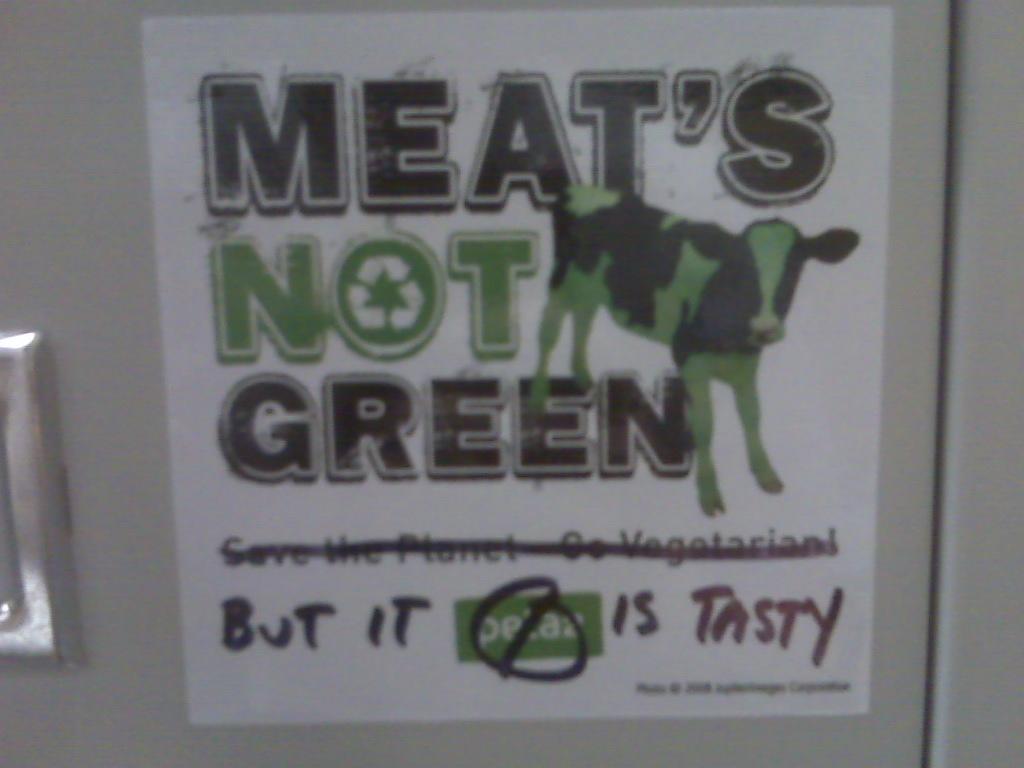What is featured in the image? There is a poster in the image. What can be found on the poster? The poster contains text and a picture of a cow. What type of trail can be seen behind the cow in the image? There is no trail visible in the image; the poster only contains text and a picture of a cow. What instrument is the cow playing in the image? There is no instrument or cow playing an instrument in the image; it only features a picture of a cow and text on a poster. 